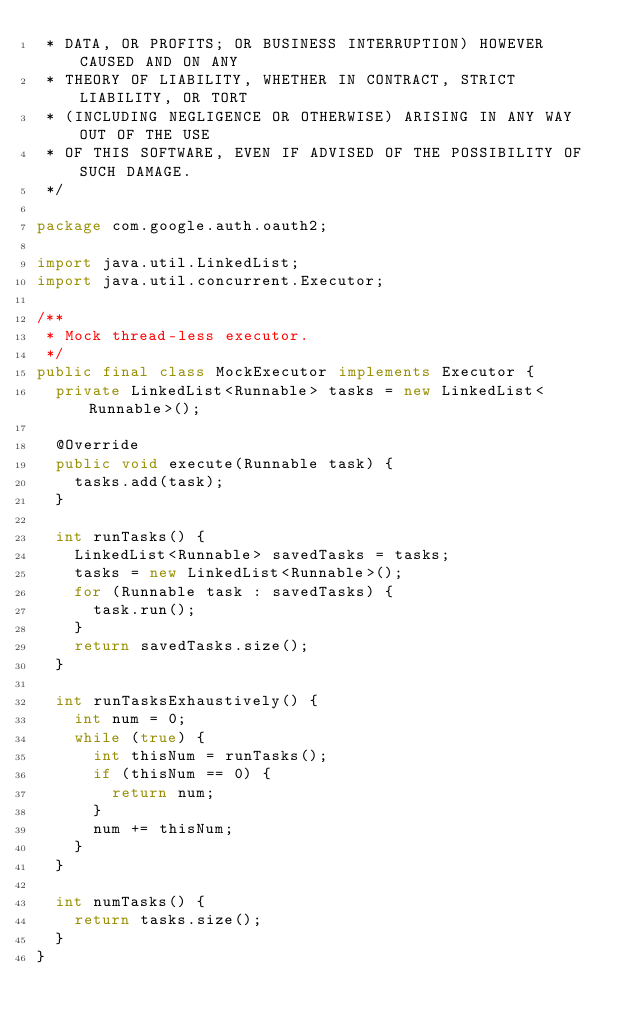<code> <loc_0><loc_0><loc_500><loc_500><_Java_> * DATA, OR PROFITS; OR BUSINESS INTERRUPTION) HOWEVER CAUSED AND ON ANY
 * THEORY OF LIABILITY, WHETHER IN CONTRACT, STRICT LIABILITY, OR TORT
 * (INCLUDING NEGLIGENCE OR OTHERWISE) ARISING IN ANY WAY OUT OF THE USE
 * OF THIS SOFTWARE, EVEN IF ADVISED OF THE POSSIBILITY OF SUCH DAMAGE.
 */

package com.google.auth.oauth2;

import java.util.LinkedList;
import java.util.concurrent.Executor;

/**
 * Mock thread-less executor.
 */
public final class MockExecutor implements Executor {
  private LinkedList<Runnable> tasks = new LinkedList<Runnable>();

  @Override
  public void execute(Runnable task) {
    tasks.add(task);
  }

  int runTasks() {
    LinkedList<Runnable> savedTasks = tasks;
    tasks = new LinkedList<Runnable>();
    for (Runnable task : savedTasks) {
      task.run();
    }
    return savedTasks.size();
  }

  int runTasksExhaustively() {
    int num = 0;
    while (true) {
      int thisNum = runTasks();
      if (thisNum == 0) {
        return num;
      }
      num += thisNum;
    }
  }

  int numTasks() {
    return tasks.size();
  }
}
</code> 